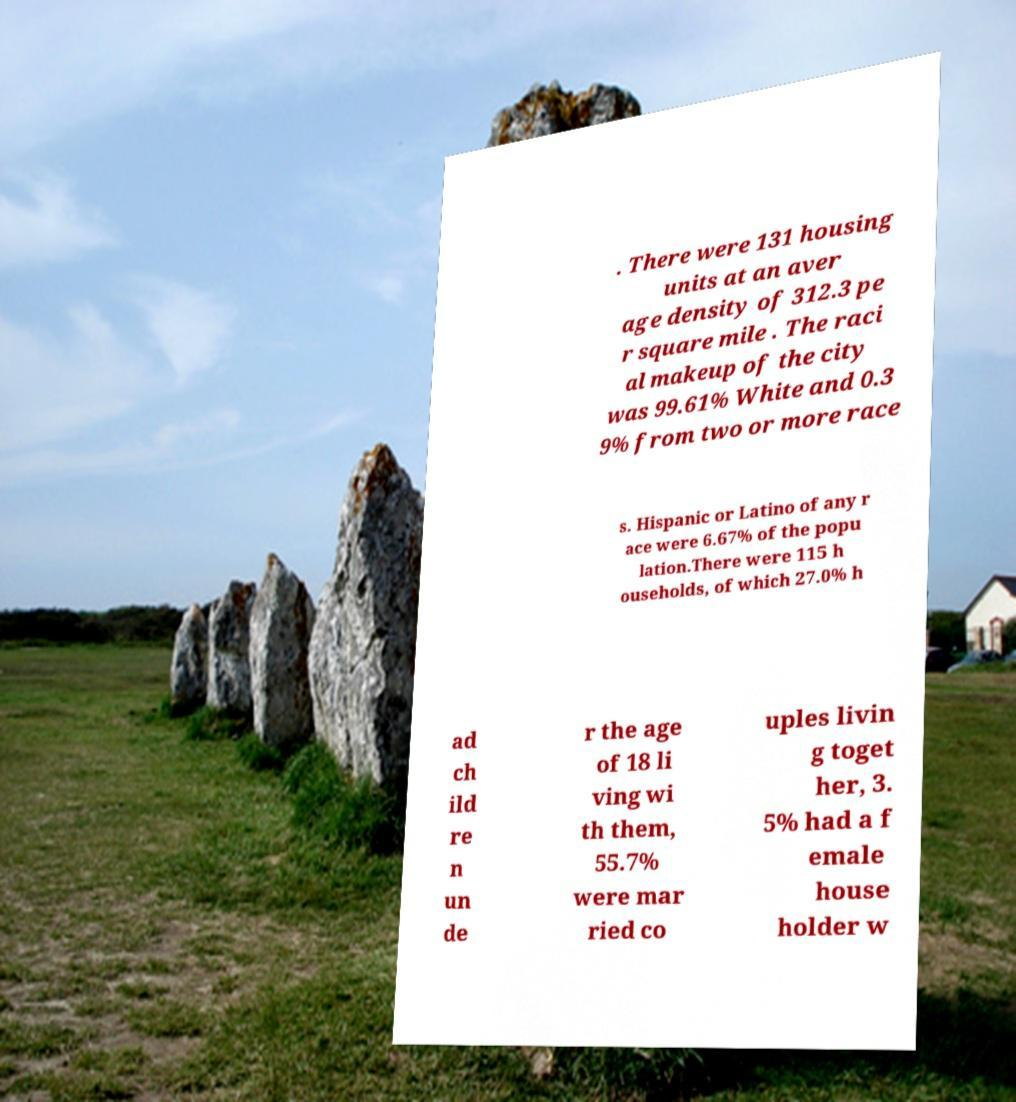Could you assist in decoding the text presented in this image and type it out clearly? . There were 131 housing units at an aver age density of 312.3 pe r square mile . The raci al makeup of the city was 99.61% White and 0.3 9% from two or more race s. Hispanic or Latino of any r ace were 6.67% of the popu lation.There were 115 h ouseholds, of which 27.0% h ad ch ild re n un de r the age of 18 li ving wi th them, 55.7% were mar ried co uples livin g toget her, 3. 5% had a f emale house holder w 